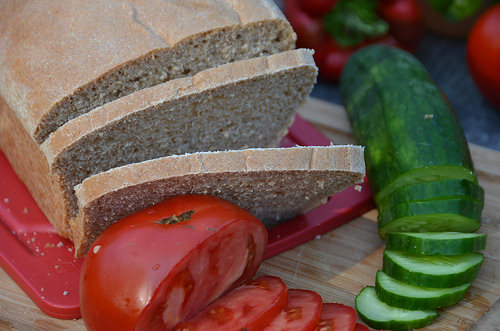<image>
Is the bread slice on the tomato? Yes. Looking at the image, I can see the bread slice is positioned on top of the tomato, with the tomato providing support. 